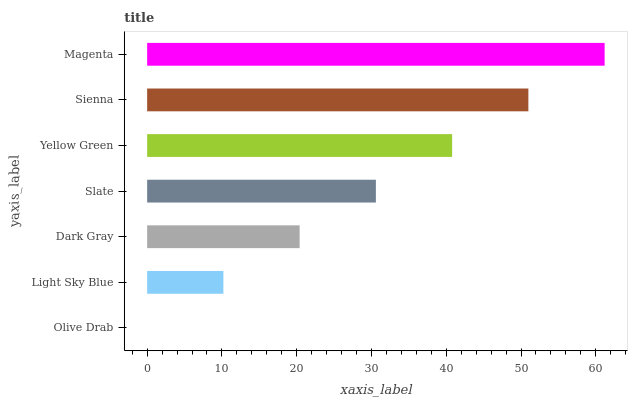Is Olive Drab the minimum?
Answer yes or no. Yes. Is Magenta the maximum?
Answer yes or no. Yes. Is Light Sky Blue the minimum?
Answer yes or no. No. Is Light Sky Blue the maximum?
Answer yes or no. No. Is Light Sky Blue greater than Olive Drab?
Answer yes or no. Yes. Is Olive Drab less than Light Sky Blue?
Answer yes or no. Yes. Is Olive Drab greater than Light Sky Blue?
Answer yes or no. No. Is Light Sky Blue less than Olive Drab?
Answer yes or no. No. Is Slate the high median?
Answer yes or no. Yes. Is Slate the low median?
Answer yes or no. Yes. Is Yellow Green the high median?
Answer yes or no. No. Is Olive Drab the low median?
Answer yes or no. No. 